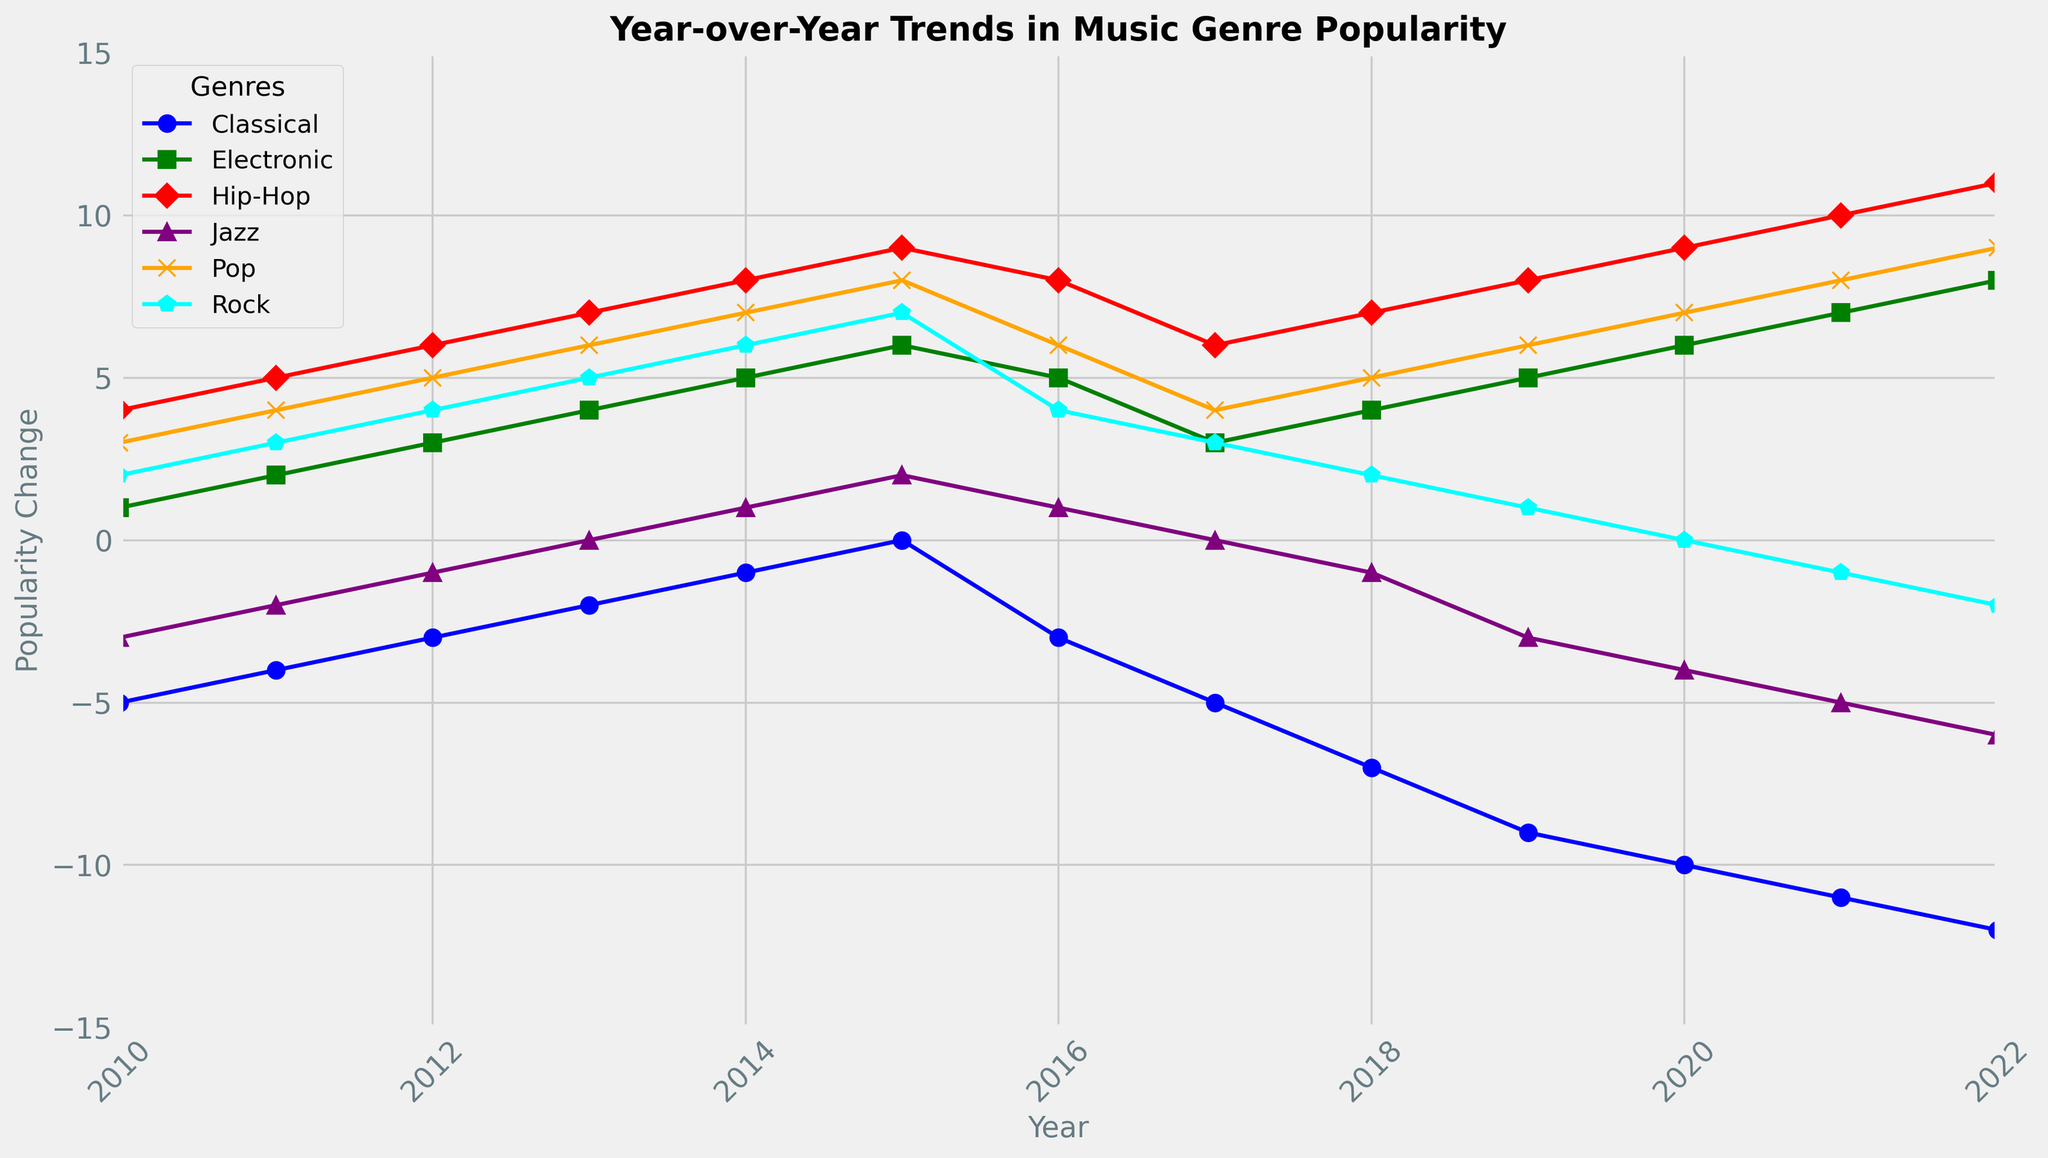Which genre experienced the most significant positive popularity change in 2022? To determine this, look at the popularity change values for each genre in 2022 and identify the highest positive value.
Answer: Hip-Hop What was the average popularity change for Jazz from 2010 to 2022? To calculate this, sum up the popularity change values for Jazz from 2010 to 2022 and divide by the number of years. The values are -3, -2, -1, 0, 1, 2, 1, 0, -1, -3, -4, -5, -6. Sum these to get -22. The average is -22/13.
Answer: -1.69 Which year did Rock see its highest popularity change, and what was the value? Looking at the line plot for Rock, identify the peak point. The highest point is in 2015. Confirm the value from the data.
Answer: 2015, 7 What is the trend of Classical music popularity change from 2010 to 2022? Observe the line for Classical music from 2010 to 2022. The line consistently trends downward from 2010 to 2022.
Answer: Decreasing Compare the popularity changes of Pop and Hip-Hop in 2020. Which one had a higher increase? Find the values for Pop and Hip-Hop in 2020. Pop had a popularity change of 7, and Hip-Hop had a popularity change of 9. Compare these values.
Answer: Hip-Hop In which years did Electronic music have a popularity change of 6 or higher? Look at the line plot for Electronic music and identify any points where the value is 6 or higher. These values occur in 2015, 2020, and 2022.
Answer: 2015, 2020, 2022 What is the overall trend for Hip-Hop from 2010 to 2022? Examine the line for Hip-Hop from 2010 to 2022. The line generally trends upward over this period.
Answer: Increasing Did Jazz ever have a year with a positive change before 2016? Check the line plot for Jazz values before 2016. The only positive changes are in 2014 and 2015.
Answer: Yes, in 2014 and 2015 How many genres experienced a negative popularity change in 2021? Look at the values for all genres in 2021 and count how many are negative. Classical, Jazz, and Rock have negative changes.
Answer: 3 Which genre had the greatest decline in popularity over the period shown? Compare the starting and ending values for each genre’s line on the plot. Classical saw the highest decline starting at -5 in 2010 and reaching -12 in 2022.
Answer: Classical 